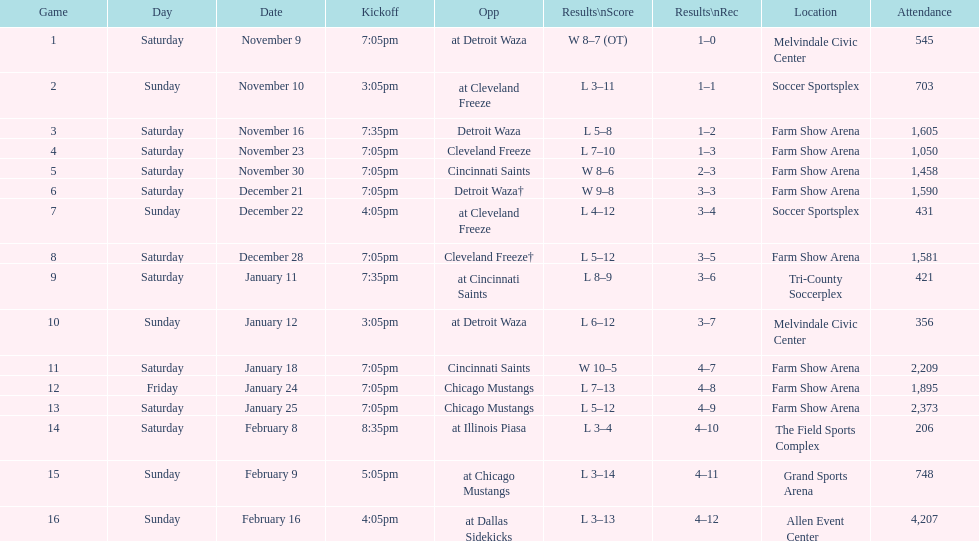How often did the team participate in home games without achieving a win? 5. 